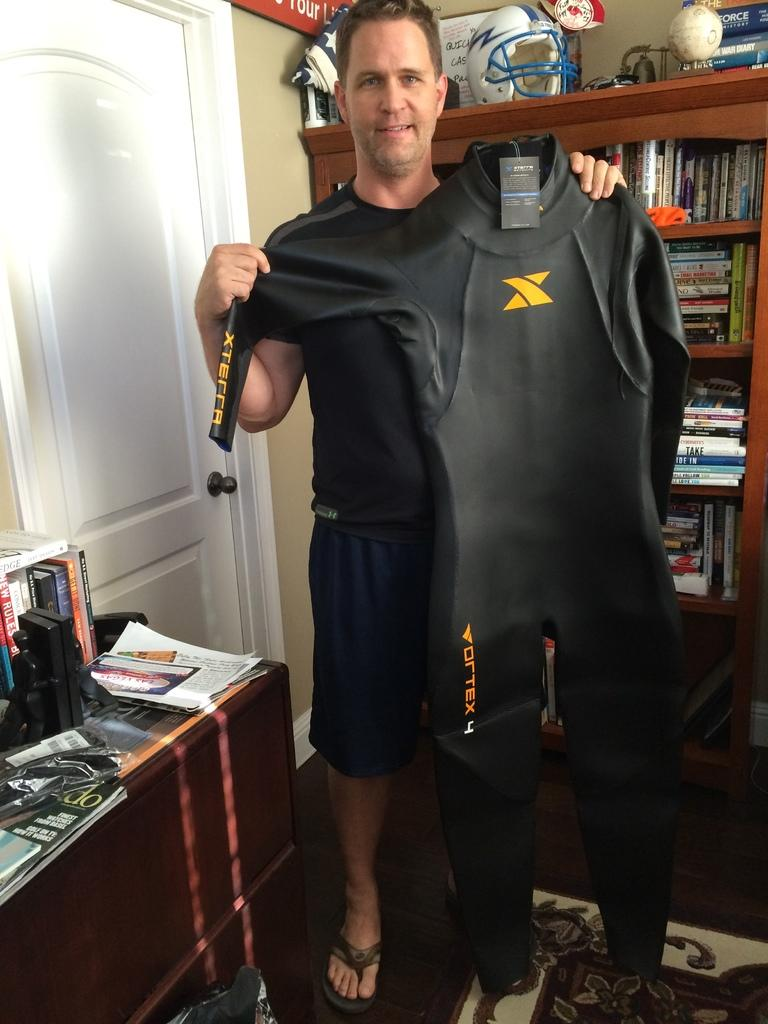<image>
Share a concise interpretation of the image provided. Man holding a black suit which says Vortex on it. 